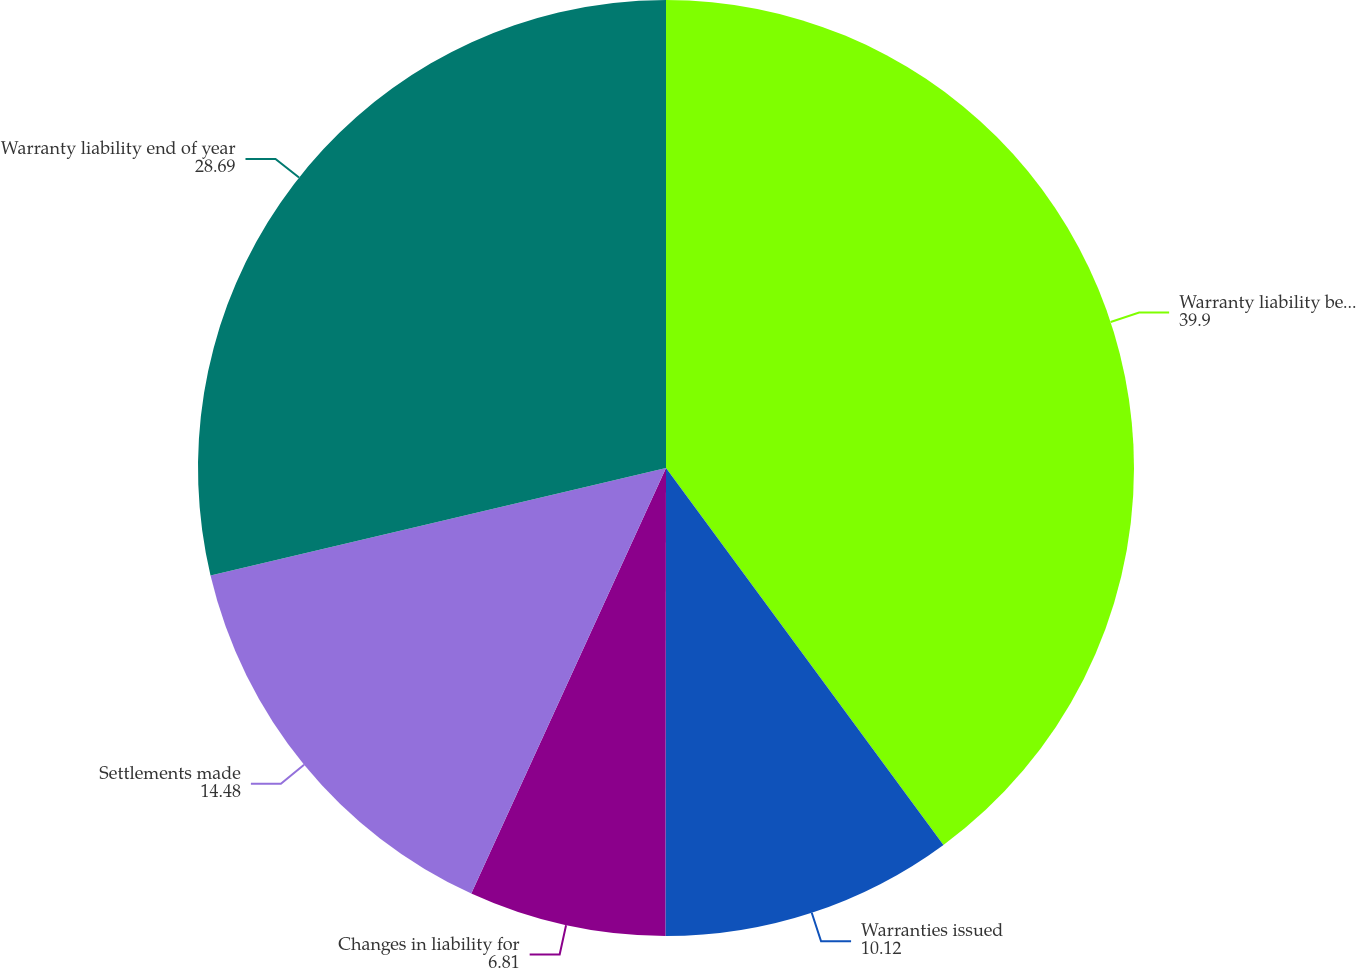Convert chart. <chart><loc_0><loc_0><loc_500><loc_500><pie_chart><fcel>Warranty liability beginning<fcel>Warranties issued<fcel>Changes in liability for<fcel>Settlements made<fcel>Warranty liability end of year<nl><fcel>39.9%<fcel>10.12%<fcel>6.81%<fcel>14.48%<fcel>28.69%<nl></chart> 